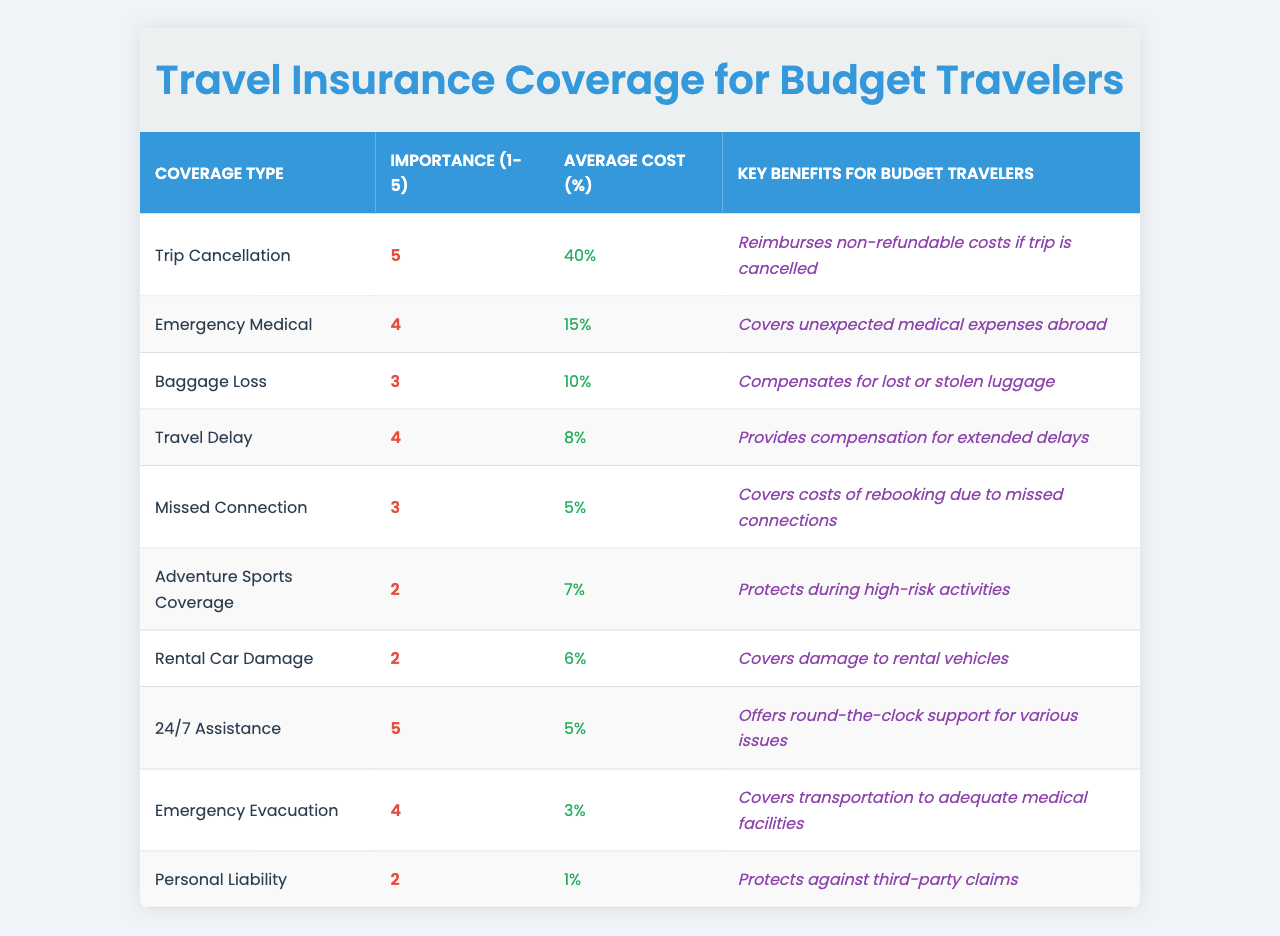What is the highest importance rating for a coverage type? The highest importance rating in the table is 5, which is assigned to "Trip Cancellation" and "24/7 Assistance".
Answer: 5 Which coverage type has the lowest average cost percentage? The coverage type with the lowest average cost percentage is "Personal Liability", which has an average cost of 1%.
Answer: 1% How many coverage types have an importance rating of 4 or higher? There are 4 coverage types with an importance rating of 4 or higher: "Trip Cancellation", "Emergency Medical", "Travel Delay", and "Emergency Evacuation".
Answer: 4 What is the average cost percentage of all coverage types listed? To find the average cost percentage, sum all percentages (40 + 15 + 10 + 8 + 5 + 7 + 6 + 5 + 3 + 1 = 100) and divide by the number of coverage types (10), which is 100/10 = 10%.
Answer: 10% Is "Adventure Sports Coverage" considered highly important for budget travelers? No, it has an importance rating of 2, which indicates it is not highly important for budget travelers.
Answer: No What key benefit is provided by "Emergency Medical" coverage? The key benefit of "Emergency Medical" coverage is that it covers unexpected medical expenses abroad.
Answer: Covers unexpected medical expenses abroad Which coverage types have an average cost percentage lower than 10%? The coverage types with an average cost percentage lower than 10% are "Travel Delay" (8%), "Missed Connection" (5%), "Emergency Evacuation" (3%), and "Personal Liability" (1%).
Answer: 4 What is the combined average cost percentage of coverage types with an importance rating of 2? The coverage types with an importance rating of 2 are "Adventure Sports Coverage" (7%), "Rental Car Damage" (6%), and "Personal Liability" (1%). Their combined average cost percentage is (7 + 6 + 1 = 14) divided by 3, which gives an average of 14/3 = 4.67%.
Answer: 4.67% Does "Baggage Loss" coverage provide any specific benefit for budget travelers? Yes, it compensates for lost or stolen luggage, which is a specific benefit for budget travelers.
Answer: Yes How does the importance of "Trip Cancellation" compare to "Missed Connection"? "Trip Cancellation" has an importance rating of 5, while "Missed Connection" has an importance rating of 3, which means "Trip Cancellation" is considered more important.
Answer: More important 